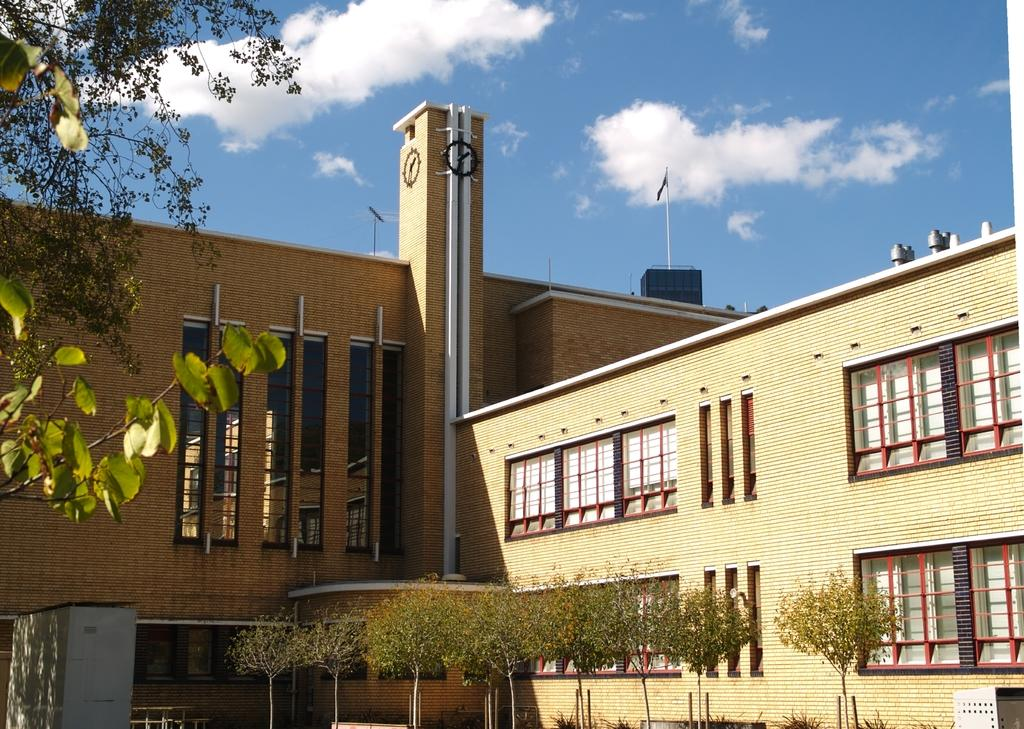What is the main subject of the image? The main subject of the image is a building. What can be seen in front of the building? There are trees in front of the building. What is located on top of the building? There is a flag on top of the building. Can you see any windows in the bedroom of the building in the image? There is no bedroom visible in the image, and therefore no windows can be seen. 